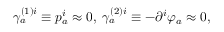Convert formula to latex. <formula><loc_0><loc_0><loc_500><loc_500>\gamma _ { a } ^ { ( 1 ) i } \equiv p _ { a } ^ { i } \approx 0 , \, \gamma _ { a } ^ { ( 2 ) i } \equiv - \partial ^ { i } \varphi _ { a } \approx 0 ,</formula> 